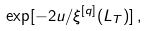<formula> <loc_0><loc_0><loc_500><loc_500>\exp [ - 2 u / \xi ^ { [ q ] } ( L _ { T } ) ] \, ,</formula> 